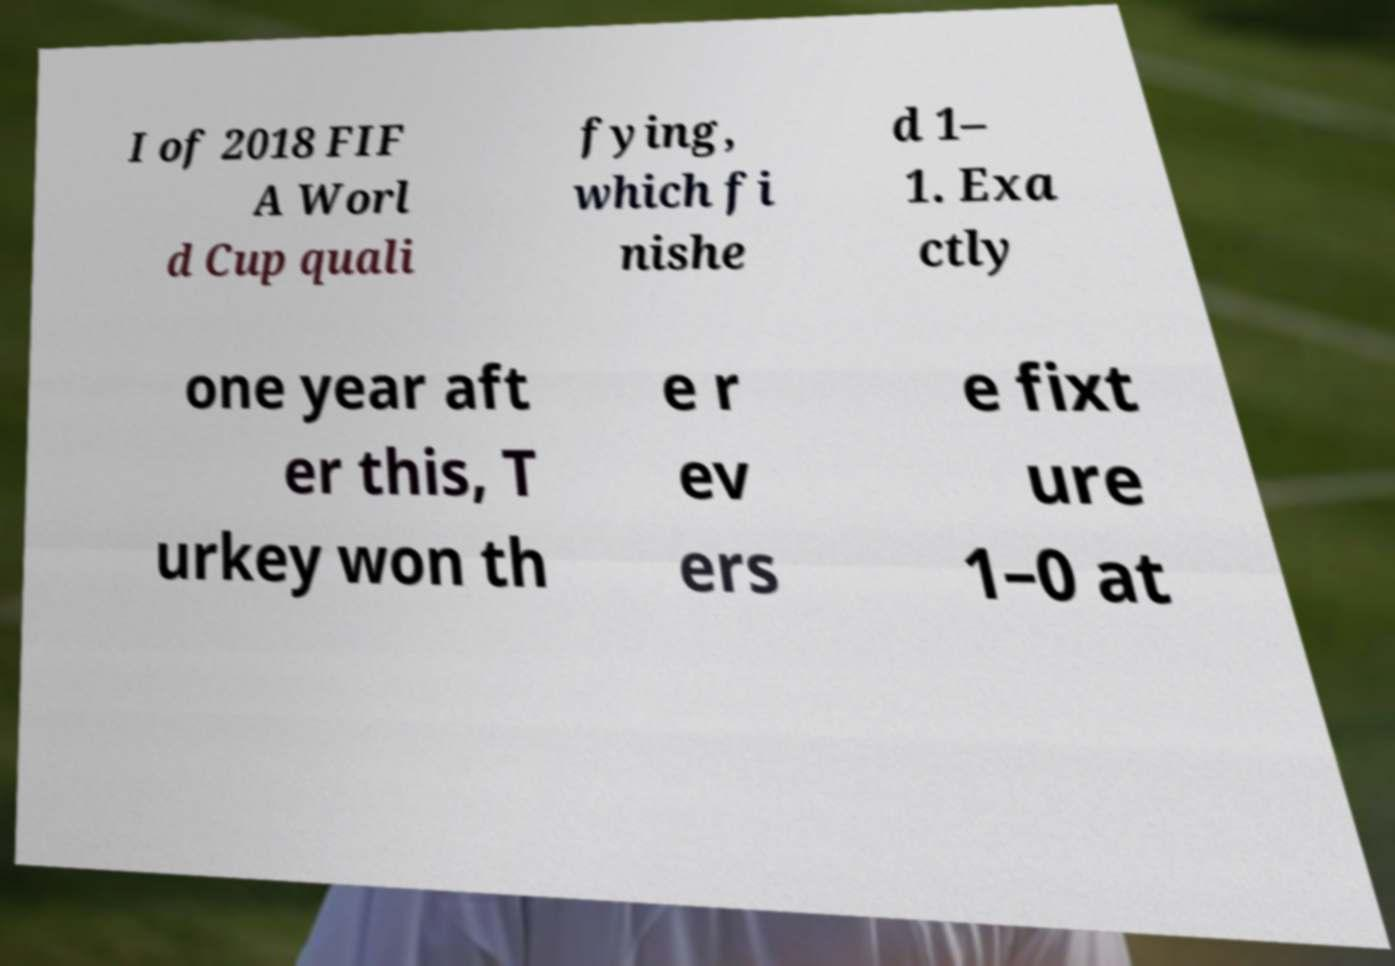Could you assist in decoding the text presented in this image and type it out clearly? I of 2018 FIF A Worl d Cup quali fying, which fi nishe d 1– 1. Exa ctly one year aft er this, T urkey won th e r ev ers e fixt ure 1–0 at 